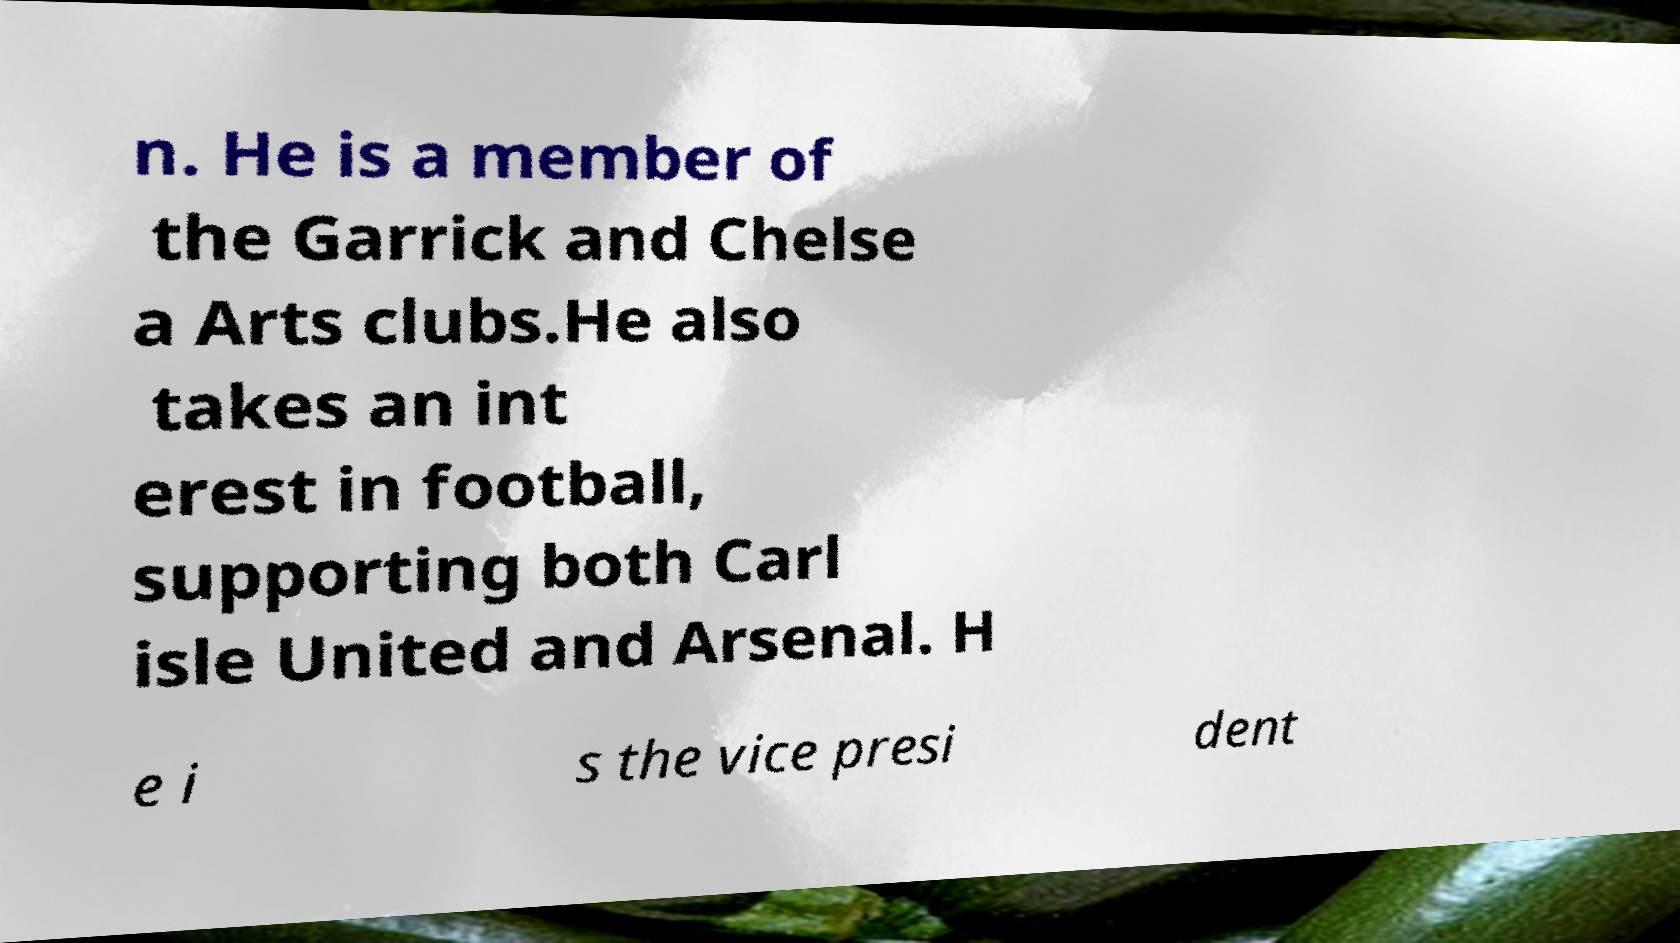Could you assist in decoding the text presented in this image and type it out clearly? n. He is a member of the Garrick and Chelse a Arts clubs.He also takes an int erest in football, supporting both Carl isle United and Arsenal. H e i s the vice presi dent 